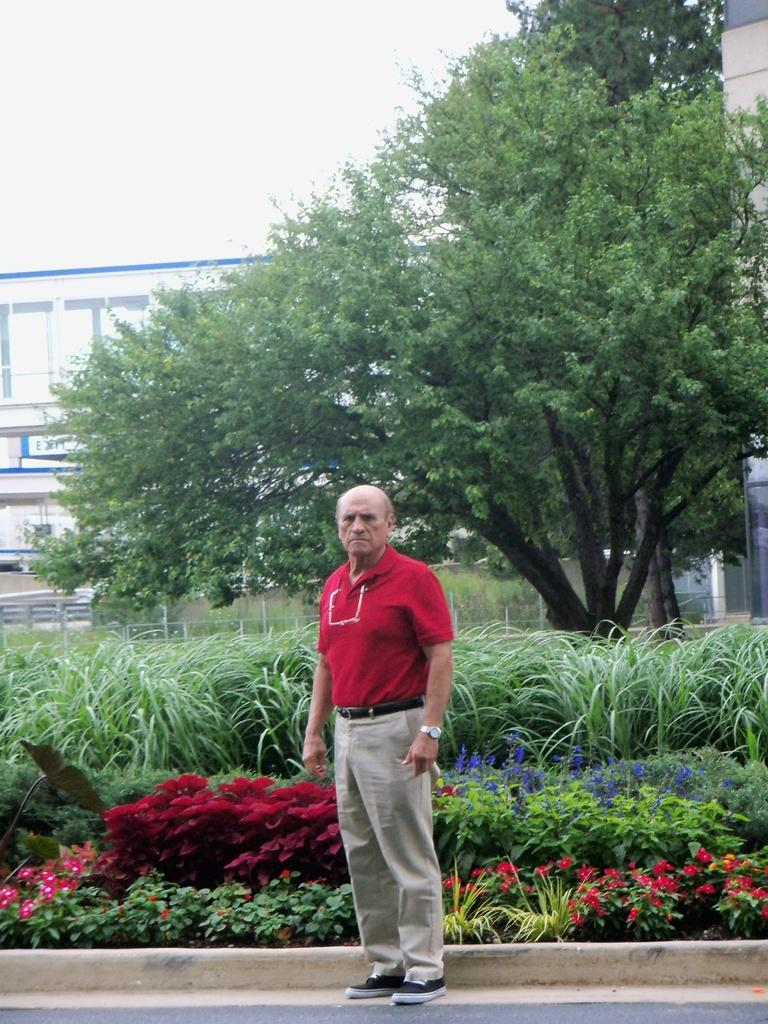What is the main subject of the image? There is a man standing in the image. Where is the man standing? The man is standing on the ground. What can be seen in the background of the image? There are flowers, plants, a fence, trees, buildings, and the sky visible in the background of the image. What type of bells can be heard ringing in the image? There are no bells present in the image, and therefore no sound can be heard. 